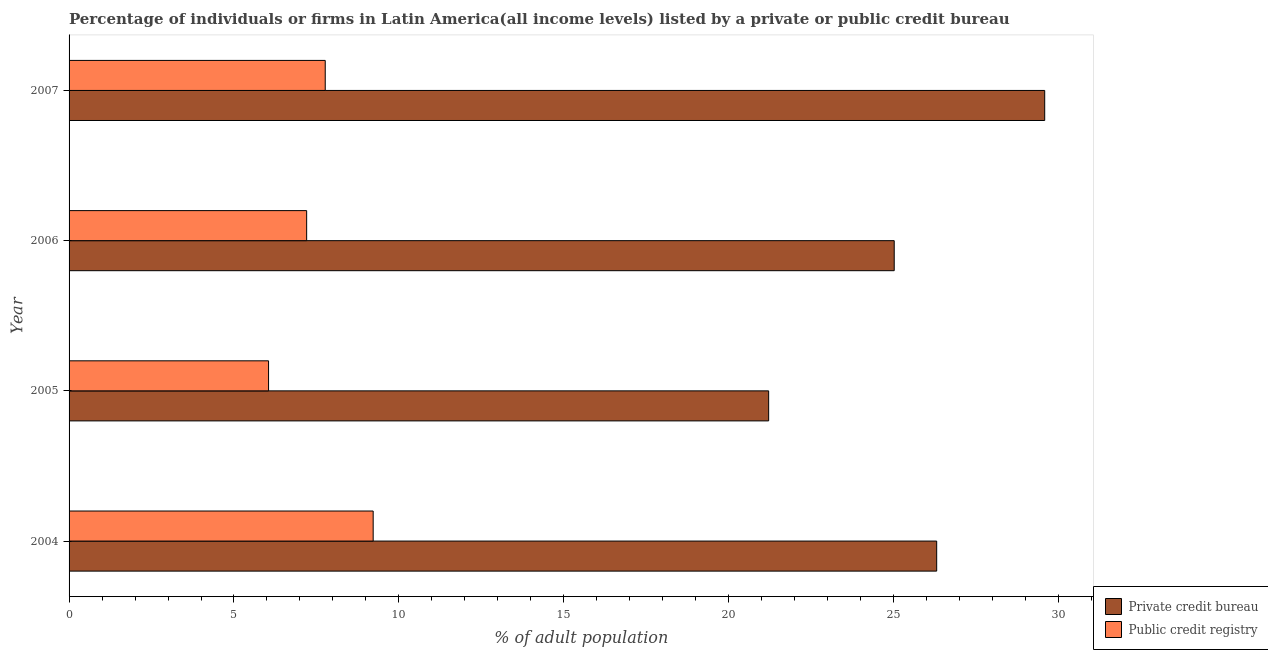How many different coloured bars are there?
Make the answer very short. 2. Are the number of bars per tick equal to the number of legend labels?
Your response must be concise. Yes. Are the number of bars on each tick of the Y-axis equal?
Make the answer very short. Yes. How many bars are there on the 2nd tick from the top?
Offer a terse response. 2. How many bars are there on the 4th tick from the bottom?
Your response must be concise. 2. What is the percentage of firms listed by private credit bureau in 2005?
Keep it short and to the point. 21.21. Across all years, what is the maximum percentage of firms listed by public credit bureau?
Provide a short and direct response. 9.22. Across all years, what is the minimum percentage of firms listed by public credit bureau?
Make the answer very short. 6.05. In which year was the percentage of firms listed by public credit bureau minimum?
Your answer should be compact. 2005. What is the total percentage of firms listed by private credit bureau in the graph?
Ensure brevity in your answer.  102.11. What is the difference between the percentage of firms listed by private credit bureau in 2006 and that in 2007?
Offer a very short reply. -4.56. What is the difference between the percentage of firms listed by public credit bureau in 2007 and the percentage of firms listed by private credit bureau in 2006?
Keep it short and to the point. -17.25. What is the average percentage of firms listed by public credit bureau per year?
Ensure brevity in your answer.  7.56. In the year 2007, what is the difference between the percentage of firms listed by public credit bureau and percentage of firms listed by private credit bureau?
Make the answer very short. -21.81. In how many years, is the percentage of firms listed by public credit bureau greater than 26 %?
Keep it short and to the point. 0. What is the ratio of the percentage of firms listed by public credit bureau in 2004 to that in 2006?
Make the answer very short. 1.28. Is the percentage of firms listed by private credit bureau in 2004 less than that in 2007?
Give a very brief answer. Yes. Is the difference between the percentage of firms listed by public credit bureau in 2005 and 2006 greater than the difference between the percentage of firms listed by private credit bureau in 2005 and 2006?
Ensure brevity in your answer.  Yes. What is the difference between the highest and the second highest percentage of firms listed by public credit bureau?
Your answer should be compact. 1.45. What is the difference between the highest and the lowest percentage of firms listed by private credit bureau?
Offer a very short reply. 8.37. Is the sum of the percentage of firms listed by private credit bureau in 2004 and 2005 greater than the maximum percentage of firms listed by public credit bureau across all years?
Your response must be concise. Yes. What does the 2nd bar from the top in 2005 represents?
Keep it short and to the point. Private credit bureau. What does the 2nd bar from the bottom in 2005 represents?
Keep it short and to the point. Public credit registry. How many bars are there?
Give a very brief answer. 8. How many years are there in the graph?
Your response must be concise. 4. What is the difference between two consecutive major ticks on the X-axis?
Your answer should be compact. 5. Are the values on the major ticks of X-axis written in scientific E-notation?
Ensure brevity in your answer.  No. Does the graph contain grids?
Your answer should be compact. No. Where does the legend appear in the graph?
Your answer should be very brief. Bottom right. What is the title of the graph?
Keep it short and to the point. Percentage of individuals or firms in Latin America(all income levels) listed by a private or public credit bureau. Does "Secondary education" appear as one of the legend labels in the graph?
Your answer should be compact. No. What is the label or title of the X-axis?
Keep it short and to the point. % of adult population. What is the label or title of the Y-axis?
Give a very brief answer. Year. What is the % of adult population of Private credit bureau in 2004?
Make the answer very short. 26.3. What is the % of adult population of Public credit registry in 2004?
Your response must be concise. 9.22. What is the % of adult population in Private credit bureau in 2005?
Offer a very short reply. 21.21. What is the % of adult population in Public credit registry in 2005?
Ensure brevity in your answer.  6.05. What is the % of adult population of Private credit bureau in 2006?
Ensure brevity in your answer.  25.02. What is the % of adult population in Public credit registry in 2006?
Ensure brevity in your answer.  7.2. What is the % of adult population of Private credit bureau in 2007?
Keep it short and to the point. 29.58. What is the % of adult population of Public credit registry in 2007?
Your answer should be very brief. 7.77. Across all years, what is the maximum % of adult population of Private credit bureau?
Give a very brief answer. 29.58. Across all years, what is the maximum % of adult population in Public credit registry?
Your response must be concise. 9.22. Across all years, what is the minimum % of adult population in Private credit bureau?
Keep it short and to the point. 21.21. Across all years, what is the minimum % of adult population of Public credit registry?
Make the answer very short. 6.05. What is the total % of adult population of Private credit bureau in the graph?
Your answer should be compact. 102.11. What is the total % of adult population in Public credit registry in the graph?
Your answer should be very brief. 30.24. What is the difference between the % of adult population of Private credit bureau in 2004 and that in 2005?
Ensure brevity in your answer.  5.09. What is the difference between the % of adult population in Public credit registry in 2004 and that in 2005?
Make the answer very short. 3.17. What is the difference between the % of adult population in Private credit bureau in 2004 and that in 2006?
Your answer should be compact. 1.29. What is the difference between the % of adult population in Public credit registry in 2004 and that in 2006?
Offer a terse response. 2.02. What is the difference between the % of adult population of Private credit bureau in 2004 and that in 2007?
Your answer should be compact. -3.27. What is the difference between the % of adult population of Public credit registry in 2004 and that in 2007?
Make the answer very short. 1.45. What is the difference between the % of adult population of Private credit bureau in 2005 and that in 2006?
Make the answer very short. -3.81. What is the difference between the % of adult population in Public credit registry in 2005 and that in 2006?
Give a very brief answer. -1.16. What is the difference between the % of adult population of Private credit bureau in 2005 and that in 2007?
Ensure brevity in your answer.  -8.37. What is the difference between the % of adult population of Public credit registry in 2005 and that in 2007?
Offer a very short reply. -1.72. What is the difference between the % of adult population in Private credit bureau in 2006 and that in 2007?
Provide a succinct answer. -4.56. What is the difference between the % of adult population of Public credit registry in 2006 and that in 2007?
Offer a very short reply. -0.56. What is the difference between the % of adult population in Private credit bureau in 2004 and the % of adult population in Public credit registry in 2005?
Your answer should be very brief. 20.26. What is the difference between the % of adult population in Private credit bureau in 2004 and the % of adult population in Public credit registry in 2006?
Provide a succinct answer. 19.1. What is the difference between the % of adult population in Private credit bureau in 2004 and the % of adult population in Public credit registry in 2007?
Make the answer very short. 18.54. What is the difference between the % of adult population of Private credit bureau in 2005 and the % of adult population of Public credit registry in 2006?
Provide a short and direct response. 14.01. What is the difference between the % of adult population of Private credit bureau in 2005 and the % of adult population of Public credit registry in 2007?
Your response must be concise. 13.44. What is the difference between the % of adult population in Private credit bureau in 2006 and the % of adult population in Public credit registry in 2007?
Your answer should be very brief. 17.25. What is the average % of adult population of Private credit bureau per year?
Make the answer very short. 25.53. What is the average % of adult population in Public credit registry per year?
Keep it short and to the point. 7.56. In the year 2004, what is the difference between the % of adult population of Private credit bureau and % of adult population of Public credit registry?
Your response must be concise. 17.09. In the year 2005, what is the difference between the % of adult population of Private credit bureau and % of adult population of Public credit registry?
Provide a succinct answer. 15.16. In the year 2006, what is the difference between the % of adult population of Private credit bureau and % of adult population of Public credit registry?
Provide a succinct answer. 17.81. In the year 2007, what is the difference between the % of adult population in Private credit bureau and % of adult population in Public credit registry?
Your answer should be compact. 21.81. What is the ratio of the % of adult population of Private credit bureau in 2004 to that in 2005?
Your response must be concise. 1.24. What is the ratio of the % of adult population of Public credit registry in 2004 to that in 2005?
Your response must be concise. 1.52. What is the ratio of the % of adult population of Private credit bureau in 2004 to that in 2006?
Offer a very short reply. 1.05. What is the ratio of the % of adult population of Public credit registry in 2004 to that in 2006?
Make the answer very short. 1.28. What is the ratio of the % of adult population in Private credit bureau in 2004 to that in 2007?
Offer a very short reply. 0.89. What is the ratio of the % of adult population of Public credit registry in 2004 to that in 2007?
Provide a short and direct response. 1.19. What is the ratio of the % of adult population of Private credit bureau in 2005 to that in 2006?
Offer a very short reply. 0.85. What is the ratio of the % of adult population of Public credit registry in 2005 to that in 2006?
Offer a terse response. 0.84. What is the ratio of the % of adult population in Private credit bureau in 2005 to that in 2007?
Your answer should be compact. 0.72. What is the ratio of the % of adult population in Public credit registry in 2005 to that in 2007?
Ensure brevity in your answer.  0.78. What is the ratio of the % of adult population in Private credit bureau in 2006 to that in 2007?
Make the answer very short. 0.85. What is the ratio of the % of adult population of Public credit registry in 2006 to that in 2007?
Offer a terse response. 0.93. What is the difference between the highest and the second highest % of adult population in Private credit bureau?
Make the answer very short. 3.27. What is the difference between the highest and the second highest % of adult population in Public credit registry?
Your answer should be compact. 1.45. What is the difference between the highest and the lowest % of adult population in Private credit bureau?
Keep it short and to the point. 8.37. What is the difference between the highest and the lowest % of adult population in Public credit registry?
Keep it short and to the point. 3.17. 